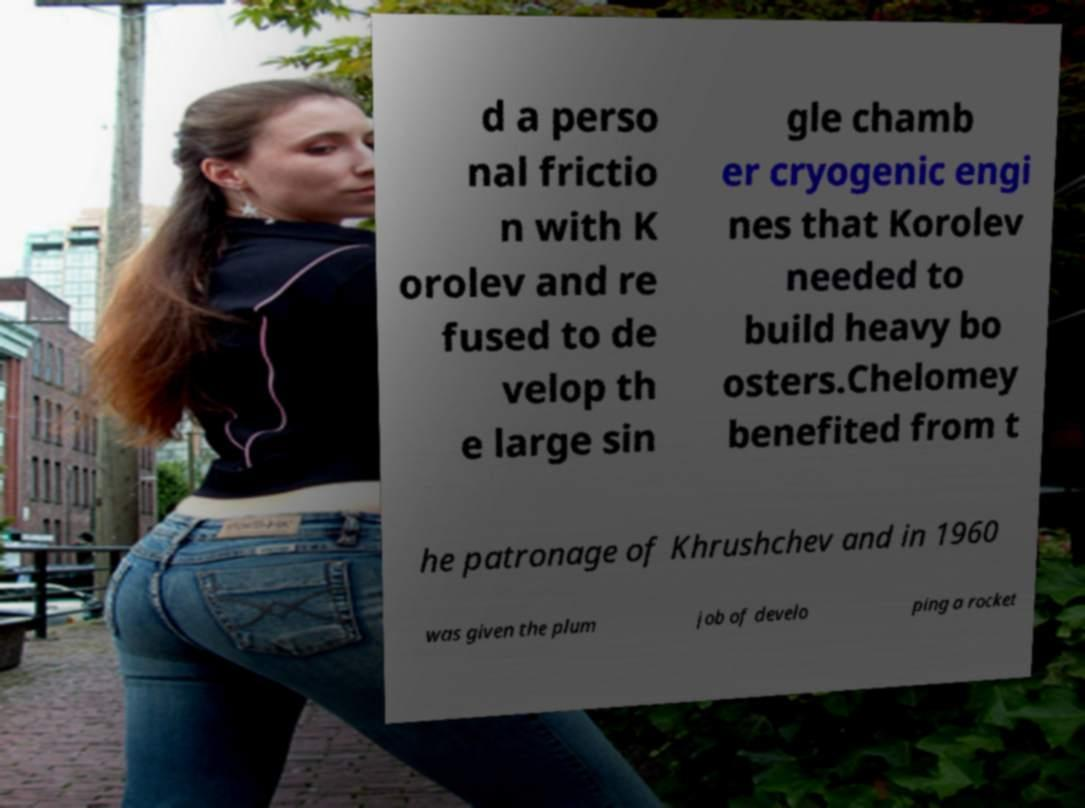There's text embedded in this image that I need extracted. Can you transcribe it verbatim? d a perso nal frictio n with K orolev and re fused to de velop th e large sin gle chamb er cryogenic engi nes that Korolev needed to build heavy bo osters.Chelomey benefited from t he patronage of Khrushchev and in 1960 was given the plum job of develo ping a rocket 